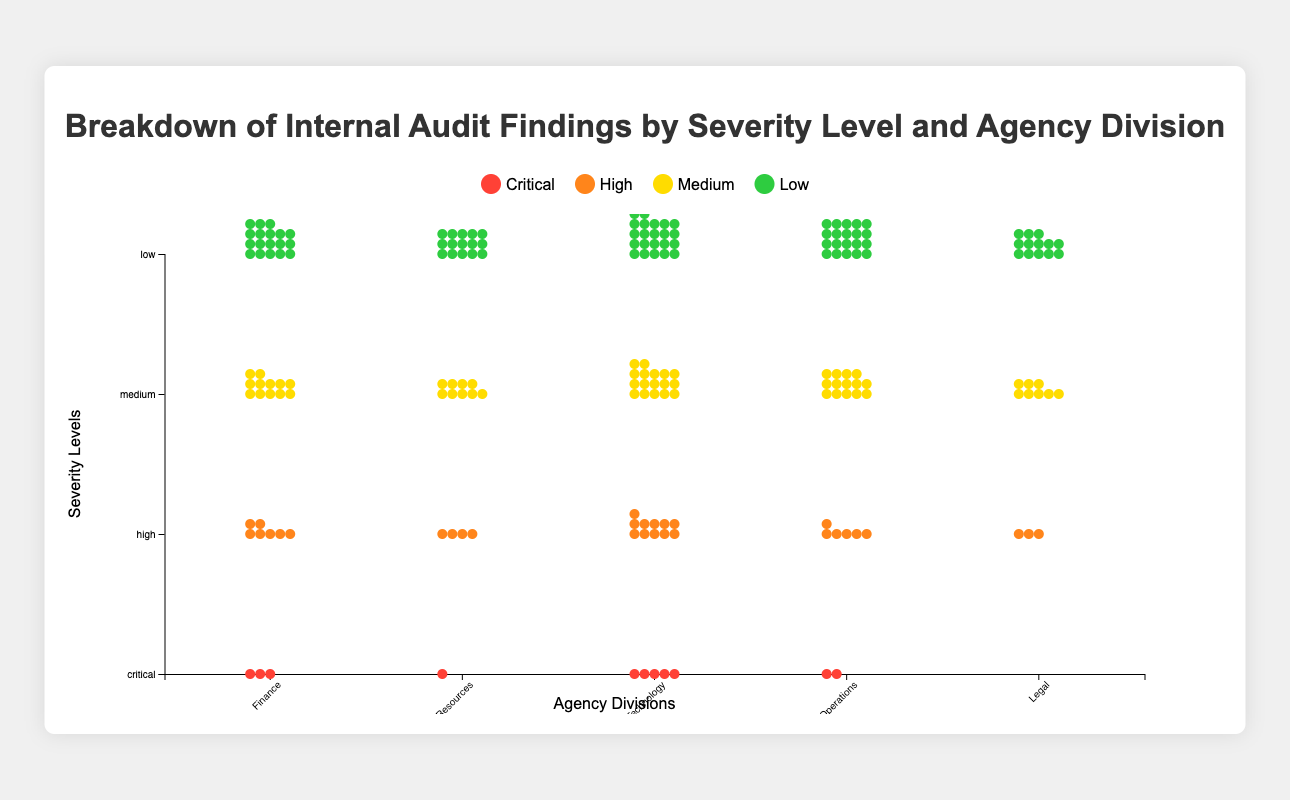What is the total number of critical findings in the Information Technology division? Look for the row representing "critical" in the "Information Technology" division column. The value is 5.
Answer: 5 Which division has the highest number of medium severity findings? Compare all divisions by looking at the "medium" row for each. The Information Technology division has 17 medium severity findings, the highest among all divisions.
Answer: Information Technology How many low severity findings are there in total across all divisions? Sum the values in the "low" row across all divisions:
Finance (18) + Human Resources (15) + Information Technology (22) + Operations (20) + Legal (13) = 88.
Answer: 88 What is the ratio of high severity findings to critical findings in the Finance division? Find the values in the "high" and "critical" rows for the Finance division. High = 7, Critical = 3. Ratio = High / Critical = 7 / 3.
Answer: 7/3 Which division has the fewest number of critical findings? Compare the "critical" row across all divisions. The Legal division has the fewest critical findings, with 0.
Answer: Legal How many more medium severity findings does Operations have compared to Human Resources? Find the values in the "medium" row for both divisions. Operations = 14, Human Resources = 9. The difference = 14 - 9.
Answer: 5 What is the difference in the number of high severity findings between the division with the most and the least? Find the values in the "high" row. Information Technology has the most (11) and Legal has the least (3). Difference = 11 - 3.
Answer: 8 Which division has slightly more than double the critical findings compared to the Legal division? Find the value of "critical" findings for the Legal division (0) and compare to other divisions. The division with slightly more than double 0 (i.e., more than 0) is Human Resources (1).
Answer: Human Resources What is the most common severity level in the Legal division? Look for the highest number in the Legal division column. The "low" severity level has the highest number with 13 findings.
Answer: Low 